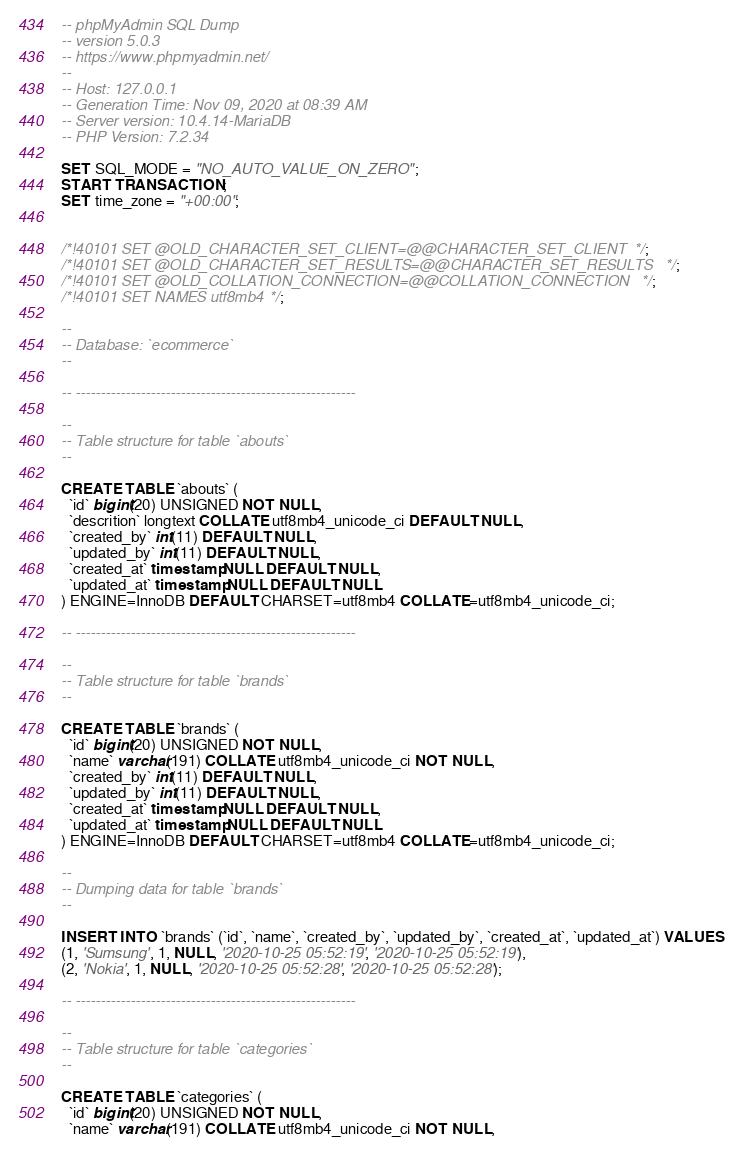<code> <loc_0><loc_0><loc_500><loc_500><_SQL_>-- phpMyAdmin SQL Dump
-- version 5.0.3
-- https://www.phpmyadmin.net/
--
-- Host: 127.0.0.1
-- Generation Time: Nov 09, 2020 at 08:39 AM
-- Server version: 10.4.14-MariaDB
-- PHP Version: 7.2.34

SET SQL_MODE = "NO_AUTO_VALUE_ON_ZERO";
START TRANSACTION;
SET time_zone = "+00:00";


/*!40101 SET @OLD_CHARACTER_SET_CLIENT=@@CHARACTER_SET_CLIENT */;
/*!40101 SET @OLD_CHARACTER_SET_RESULTS=@@CHARACTER_SET_RESULTS */;
/*!40101 SET @OLD_COLLATION_CONNECTION=@@COLLATION_CONNECTION */;
/*!40101 SET NAMES utf8mb4 */;

--
-- Database: `ecommerce`
--

-- --------------------------------------------------------

--
-- Table structure for table `abouts`
--

CREATE TABLE `abouts` (
  `id` bigint(20) UNSIGNED NOT NULL,
  `descrition` longtext COLLATE utf8mb4_unicode_ci DEFAULT NULL,
  `created_by` int(11) DEFAULT NULL,
  `updated_by` int(11) DEFAULT NULL,
  `created_at` timestamp NULL DEFAULT NULL,
  `updated_at` timestamp NULL DEFAULT NULL
) ENGINE=InnoDB DEFAULT CHARSET=utf8mb4 COLLATE=utf8mb4_unicode_ci;

-- --------------------------------------------------------

--
-- Table structure for table `brands`
--

CREATE TABLE `brands` (
  `id` bigint(20) UNSIGNED NOT NULL,
  `name` varchar(191) COLLATE utf8mb4_unicode_ci NOT NULL,
  `created_by` int(11) DEFAULT NULL,
  `updated_by` int(11) DEFAULT NULL,
  `created_at` timestamp NULL DEFAULT NULL,
  `updated_at` timestamp NULL DEFAULT NULL
) ENGINE=InnoDB DEFAULT CHARSET=utf8mb4 COLLATE=utf8mb4_unicode_ci;

--
-- Dumping data for table `brands`
--

INSERT INTO `brands` (`id`, `name`, `created_by`, `updated_by`, `created_at`, `updated_at`) VALUES
(1, 'Sumsung', 1, NULL, '2020-10-25 05:52:19', '2020-10-25 05:52:19'),
(2, 'Nokia', 1, NULL, '2020-10-25 05:52:28', '2020-10-25 05:52:28');

-- --------------------------------------------------------

--
-- Table structure for table `categories`
--

CREATE TABLE `categories` (
  `id` bigint(20) UNSIGNED NOT NULL,
  `name` varchar(191) COLLATE utf8mb4_unicode_ci NOT NULL,</code> 